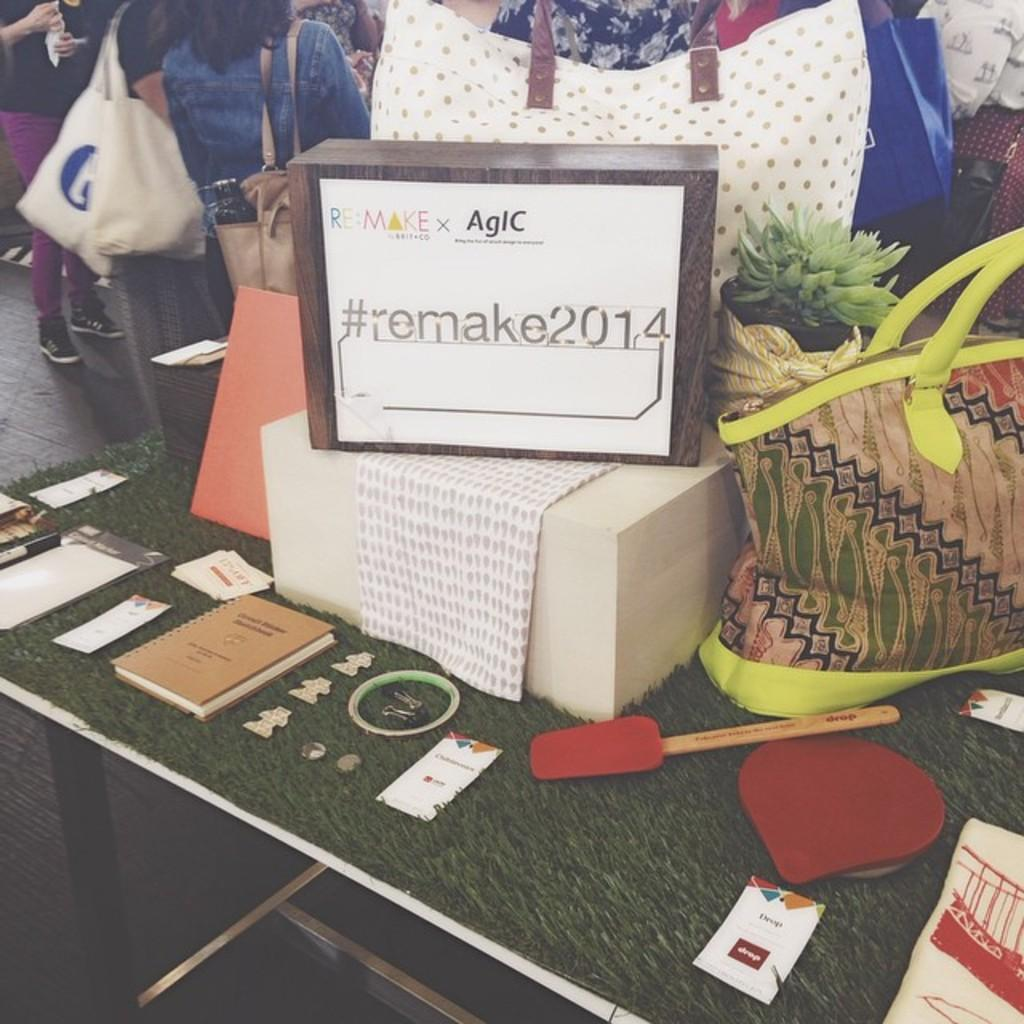What is the main piece of furniture in the image? There is a table in the image. What items can be seen on the table? There are bags, boxes, cloth, bats, papers, and other objects on the table. Can you describe the people in the background of the image? There are people standing in the background of the image. Where is the cushion located in the image? There is no cushion present in the image. What type of secretary is working at the table in the image? There is no secretary present in the image. 